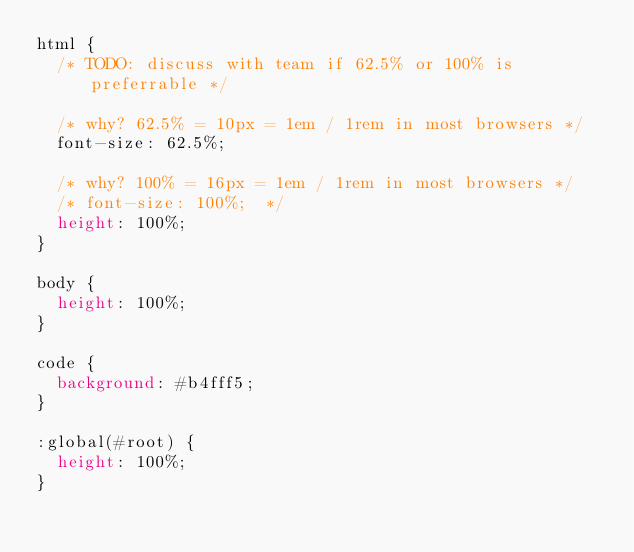<code> <loc_0><loc_0><loc_500><loc_500><_CSS_>html {
  /* TODO: discuss with team if 62.5% or 100% is preferrable */

  /* why? 62.5% = 10px = 1em / 1rem in most browsers */
  font-size: 62.5%;

  /* why? 100% = 16px = 1em / 1rem in most browsers */
  /* font-size: 100%;  */
  height: 100%;
}

body {
  height: 100%;
}

code {
  background: #b4fff5;
}

:global(#root) {
  height: 100%;
}
</code> 